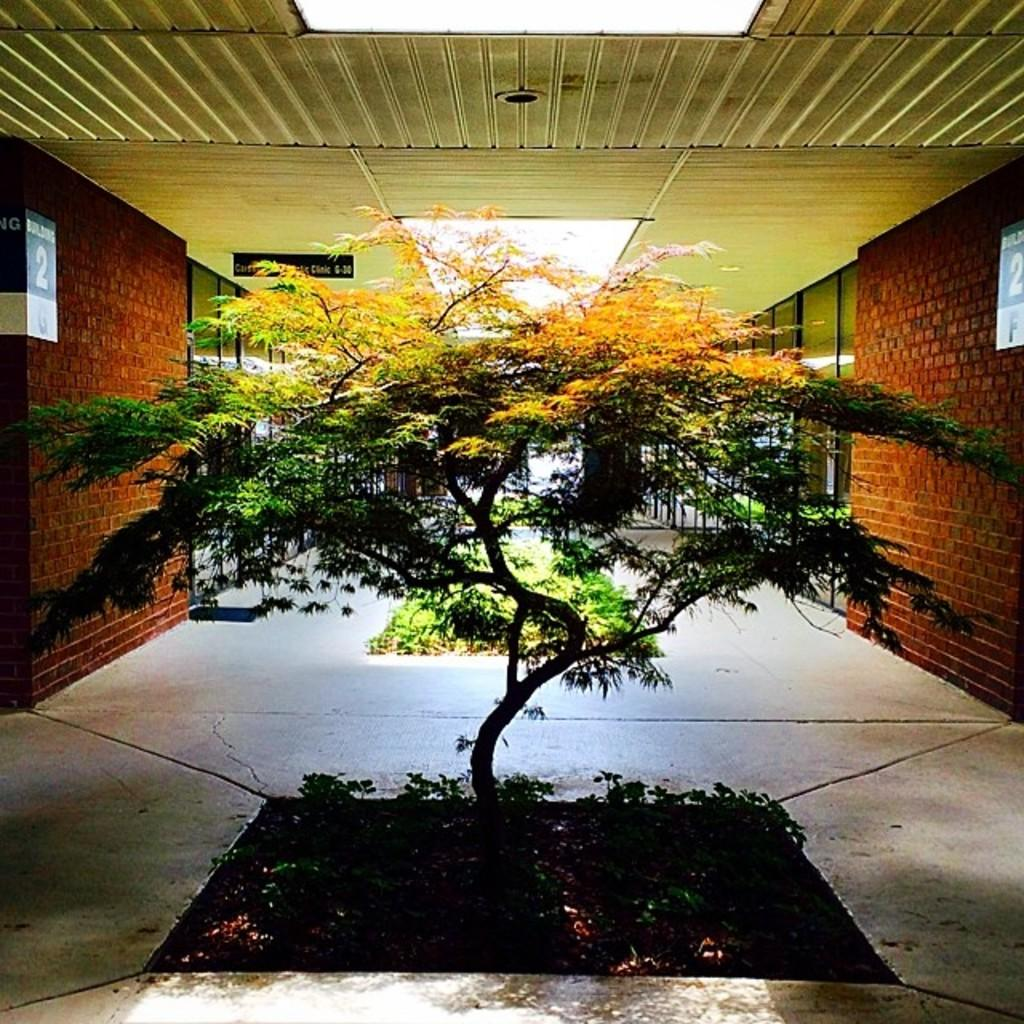What is present in the image? There is a plant in the image. What can be said about the color of the plant? The plant is green. What can be seen in the background of the image? There are glass windows and the sky visible in the background. How is the sky described in the image? The color of the sky is described as white. Where is the button located in the image? There is no button present in the image. What type of alarm can be heard in the image? There is no alarm present in the image, and therefore no sound can be heard. 